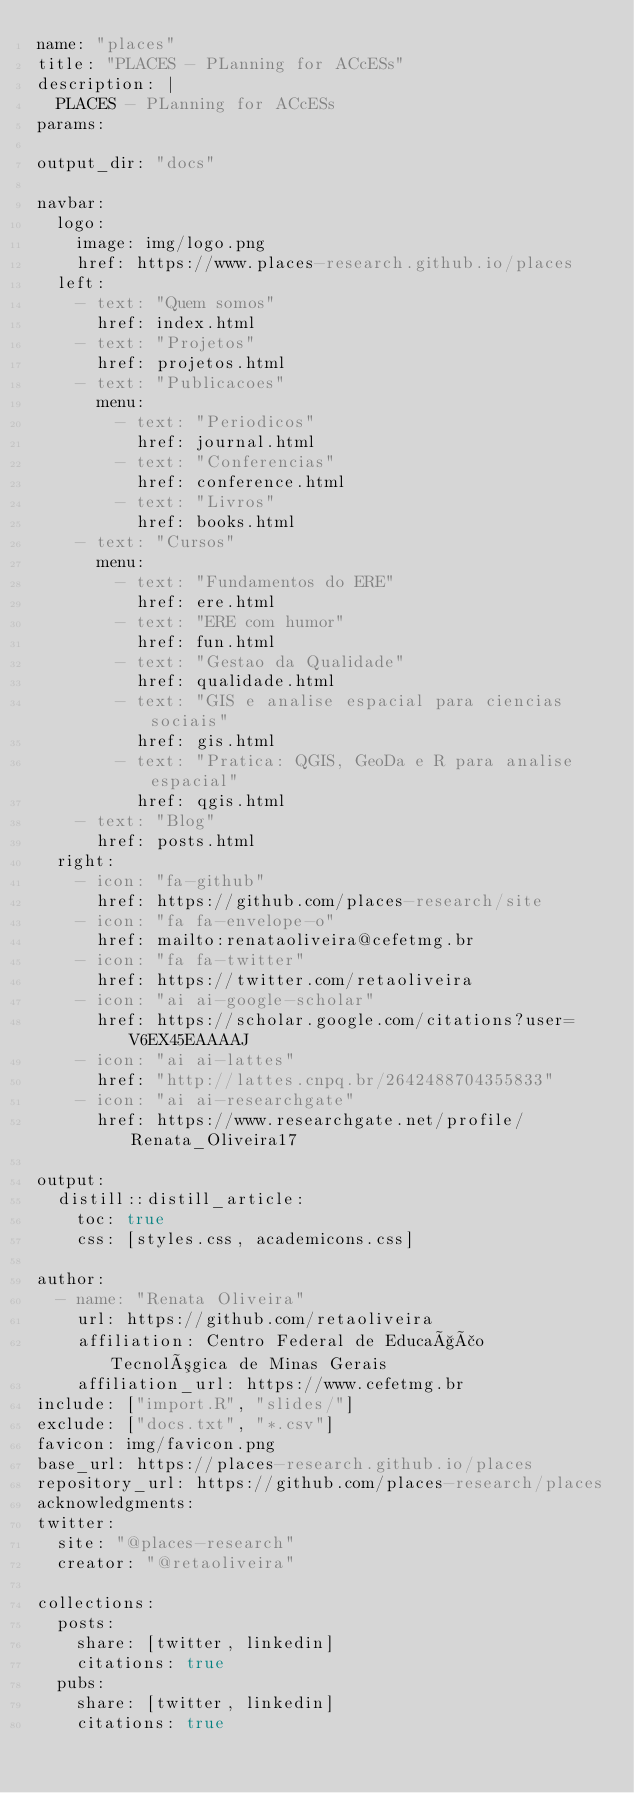Convert code to text. <code><loc_0><loc_0><loc_500><loc_500><_YAML_>name: "places"
title: "PLACES - PLanning for ACcESs"
description: |
  PLACES - PLanning for ACcESs
params:
  
output_dir: "docs"

navbar:
  logo:
    image: img/logo.png
    href: https://www.places-research.github.io/places
  left:
    - text: "Quem somos"
      href: index.html
    - text: "Projetos"
      href: projetos.html
    - text: "Publicacoes"
      menu:
        - text: "Periodicos"
          href: journal.html
        - text: "Conferencias"
          href: conference.html
        - text: "Livros"
          href: books.html
    - text: "Cursos"
      menu:
        - text: "Fundamentos do ERE"
          href: ere.html
        - text: "ERE com humor"
          href: fun.html
        - text: "Gestao da Qualidade"
          href: qualidade.html
        - text: "GIS e analise espacial para ciencias sociais"
          href: gis.html
        - text: "Pratica: QGIS, GeoDa e R para analise espacial"
          href: qgis.html
    - text: "Blog"
      href: posts.html
  right:
    - icon: "fa-github"
      href: https://github.com/places-research/site
    - icon: "fa fa-envelope-o"
      href: mailto:renataoliveira@cefetmg.br
    - icon: "fa fa-twitter"
      href: https://twitter.com/retaoliveira
    - icon: "ai ai-google-scholar"
      href: https://scholar.google.com/citations?user=V6EX45EAAAAJ
    - icon: "ai ai-lattes"
      href: "http://lattes.cnpq.br/2642488704355833"
    - icon: "ai ai-researchgate"  
      href: https://www.researchgate.net/profile/Renata_Oliveira17

output:
  distill::distill_article:
    toc: true
    css: [styles.css, academicons.css]

author:
  - name: "Renata Oliveira"
    url: https://github.com/retaoliveira
    affiliation: Centro Federal de Educação Tecnológica de Minas Gerais
    affiliation_url: https://www.cefetmg.br
include: ["import.R", "slides/"]
exclude: ["docs.txt", "*.csv"]
favicon: img/favicon.png
base_url: https://places-research.github.io/places
repository_url: https://github.com/places-research/places
acknowledgments: 
twitter:
  site: "@places-research"
  creator: "@retaoliveira"
  
collections:
  posts:
    share: [twitter, linkedin]
    citations: true
  pubs:
    share: [twitter, linkedin]
    citations: true
    
  </code> 